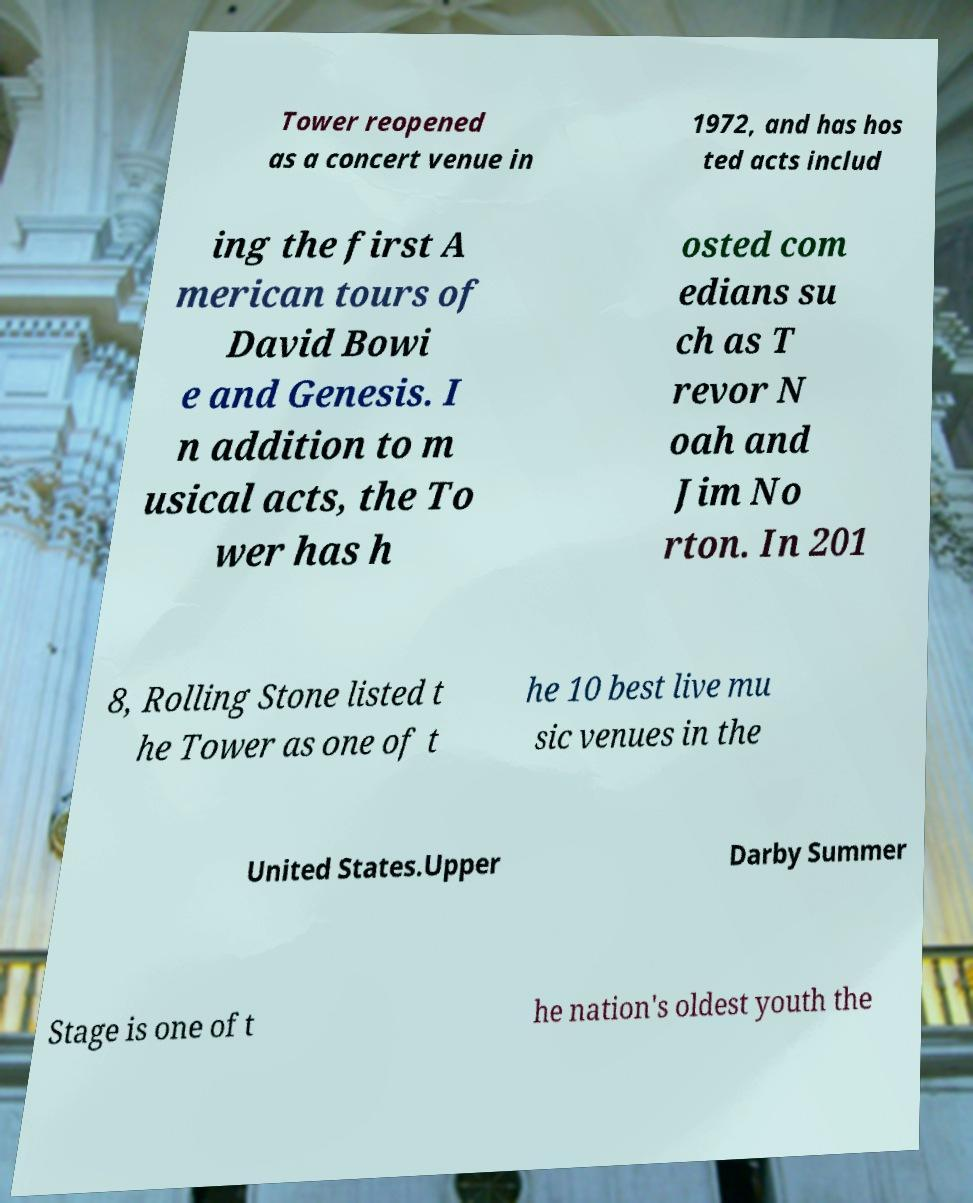Can you read and provide the text displayed in the image?This photo seems to have some interesting text. Can you extract and type it out for me? Tower reopened as a concert venue in 1972, and has hos ted acts includ ing the first A merican tours of David Bowi e and Genesis. I n addition to m usical acts, the To wer has h osted com edians su ch as T revor N oah and Jim No rton. In 201 8, Rolling Stone listed t he Tower as one of t he 10 best live mu sic venues in the United States.Upper Darby Summer Stage is one of t he nation's oldest youth the 